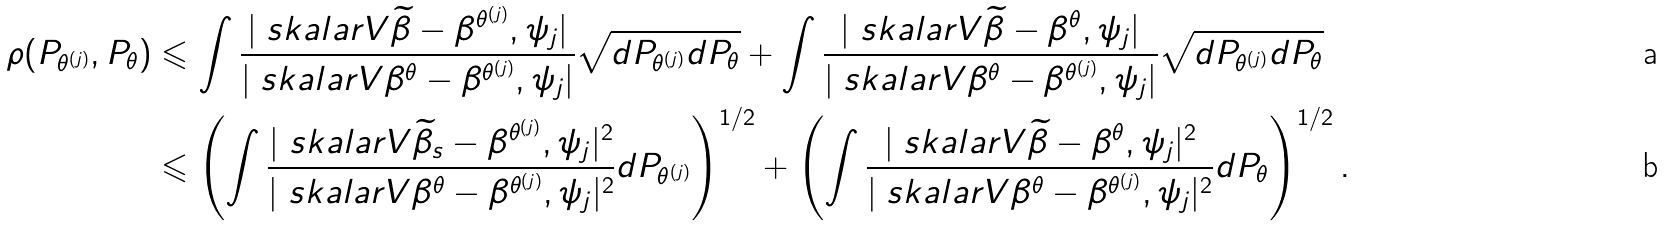<formula> <loc_0><loc_0><loc_500><loc_500>\rho ( P _ { \theta ^ { ( j ) } } , P _ { \theta } ) & \leqslant \int \frac { | \ s k a l a r V { \widetilde { \beta } - \beta ^ { \theta ^ { ( j ) } } , \psi _ { j } } | } { | \ s k a l a r V { \beta ^ { \theta } - \beta ^ { \theta ^ { ( j ) } } , \psi _ { j } } | } \sqrt { d P _ { \theta ^ { ( j ) } } d P _ { \theta } } + \int \frac { | \ s k a l a r V { \widetilde { \beta } - \beta ^ { \theta } , \psi _ { j } } | } { | \ s k a l a r V { \beta ^ { \theta } - \beta ^ { \theta ^ { ( j ) } } , \psi _ { j } } | } \sqrt { d P _ { \theta ^ { ( j ) } } d P _ { \theta } } \\ & \leqslant \left ( \int \frac { | \ s k a l a r V { \widetilde { \beta } _ { s } - \beta ^ { \theta ^ { ( j ) } } , \psi _ { j } } | ^ { 2 } } { | \ s k a l a r V { \beta ^ { \theta } - \beta ^ { \theta ^ { ( j ) } } , \psi _ { j } } | ^ { 2 } } d P _ { \theta ^ { ( j ) } } \right ) ^ { 1 / 2 } + \left ( \int \frac { | \ s k a l a r V { \widetilde { \beta } - \beta ^ { \theta } , \psi _ { j } } | ^ { 2 } } { | \ s k a l a r V { \beta ^ { \theta } - \beta ^ { \theta ^ { ( j ) } } , \psi _ { j } } | ^ { 2 } } d P _ { \theta } \right ) ^ { 1 / 2 } .</formula> 